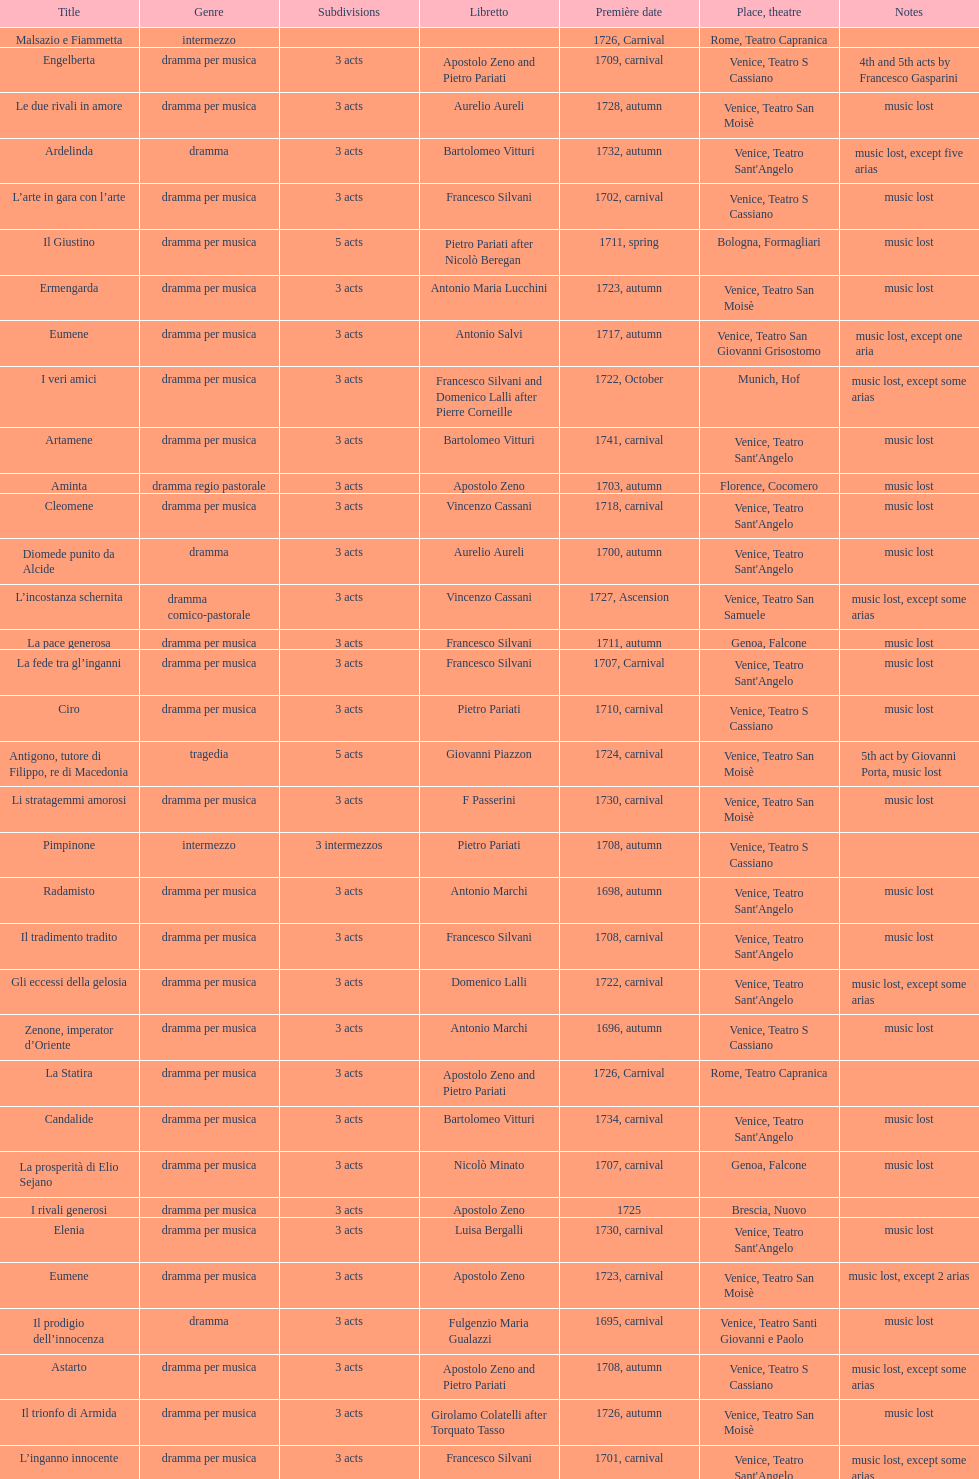What comes after ardelinda? Candalide. 